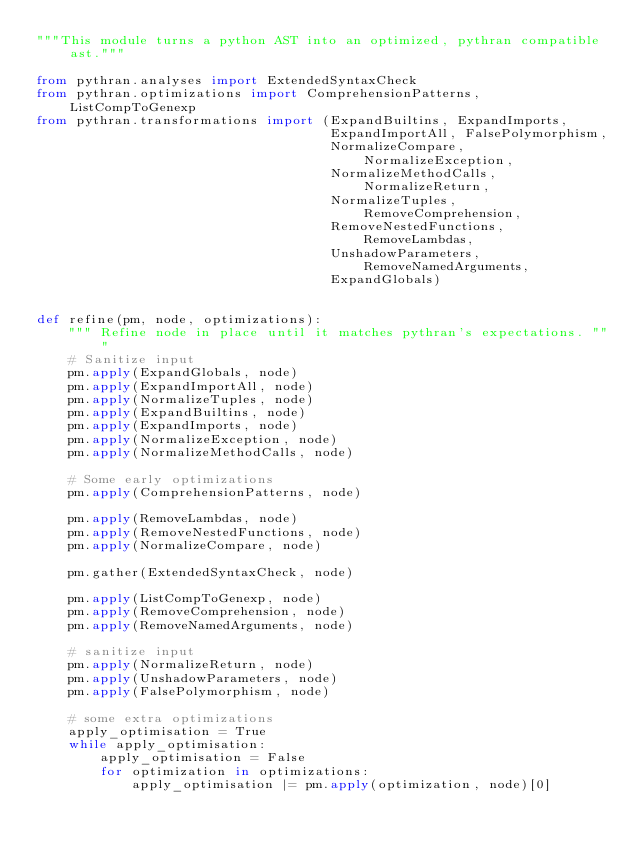<code> <loc_0><loc_0><loc_500><loc_500><_Python_>"""This module turns a python AST into an optimized, pythran compatible ast."""

from pythran.analyses import ExtendedSyntaxCheck
from pythran.optimizations import ComprehensionPatterns, ListCompToGenexp
from pythran.transformations import (ExpandBuiltins, ExpandImports,
                                     ExpandImportAll, FalsePolymorphism,
                                     NormalizeCompare, NormalizeException,
                                     NormalizeMethodCalls, NormalizeReturn,
                                     NormalizeTuples, RemoveComprehension,
                                     RemoveNestedFunctions, RemoveLambdas,
                                     UnshadowParameters, RemoveNamedArguments,
                                     ExpandGlobals)


def refine(pm, node, optimizations):
    """ Refine node in place until it matches pythran's expectations. """
    # Sanitize input
    pm.apply(ExpandGlobals, node)
    pm.apply(ExpandImportAll, node)
    pm.apply(NormalizeTuples, node)
    pm.apply(ExpandBuiltins, node)
    pm.apply(ExpandImports, node)
    pm.apply(NormalizeException, node)
    pm.apply(NormalizeMethodCalls, node)

    # Some early optimizations
    pm.apply(ComprehensionPatterns, node)

    pm.apply(RemoveLambdas, node)
    pm.apply(RemoveNestedFunctions, node)
    pm.apply(NormalizeCompare, node)

    pm.gather(ExtendedSyntaxCheck, node)

    pm.apply(ListCompToGenexp, node)
    pm.apply(RemoveComprehension, node)
    pm.apply(RemoveNamedArguments, node)

    # sanitize input
    pm.apply(NormalizeReturn, node)
    pm.apply(UnshadowParameters, node)
    pm.apply(FalsePolymorphism, node)

    # some extra optimizations
    apply_optimisation = True
    while apply_optimisation:
        apply_optimisation = False
        for optimization in optimizations:
            apply_optimisation |= pm.apply(optimization, node)[0]
</code> 